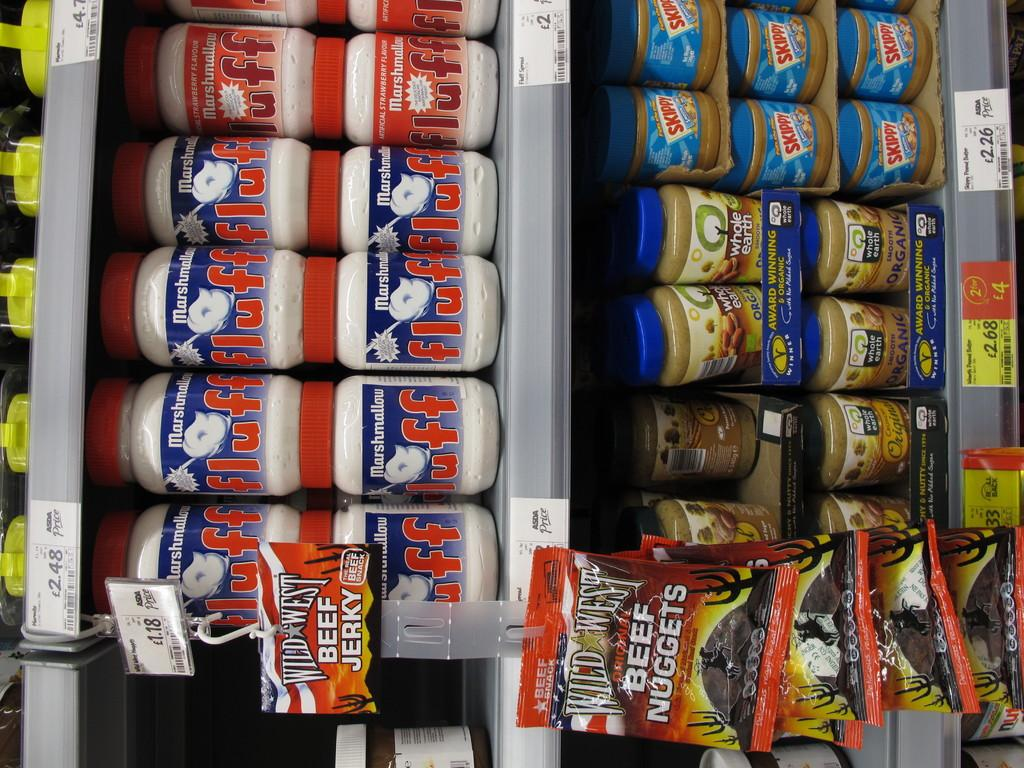<image>
Create a compact narrative representing the image presented. A row of Fluff marshmellows is on a shelf above skippy peanut butter. 